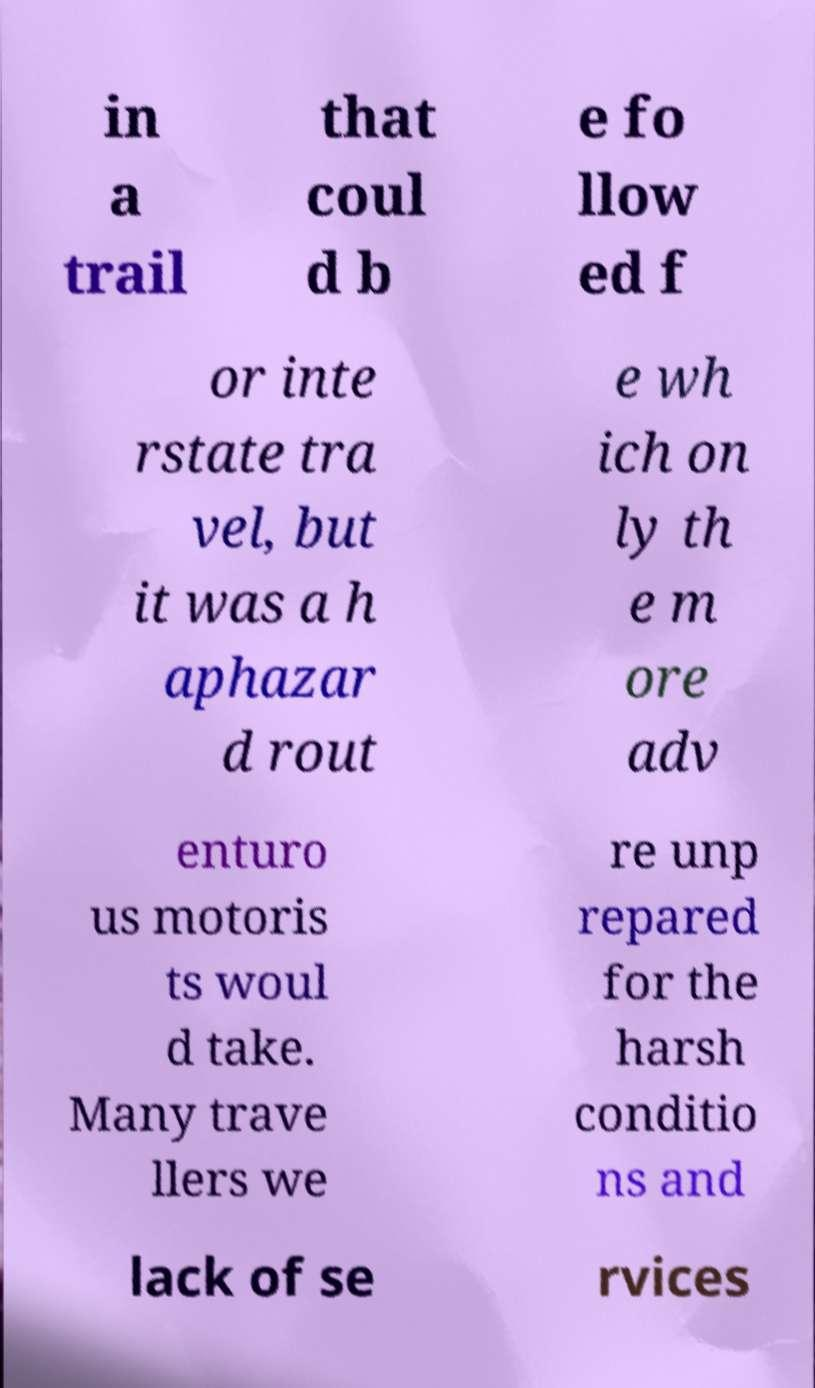Can you read and provide the text displayed in the image?This photo seems to have some interesting text. Can you extract and type it out for me? in a trail that coul d b e fo llow ed f or inte rstate tra vel, but it was a h aphazar d rout e wh ich on ly th e m ore adv enturo us motoris ts woul d take. Many trave llers we re unp repared for the harsh conditio ns and lack of se rvices 